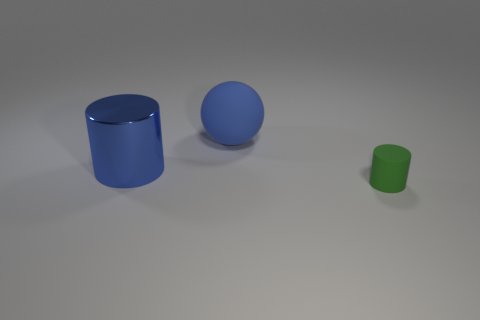How many objects are depicted in the image? There are three objects in the image: a large blue cylinder, a medium-sized blue sphere, and a small green cylinder. 